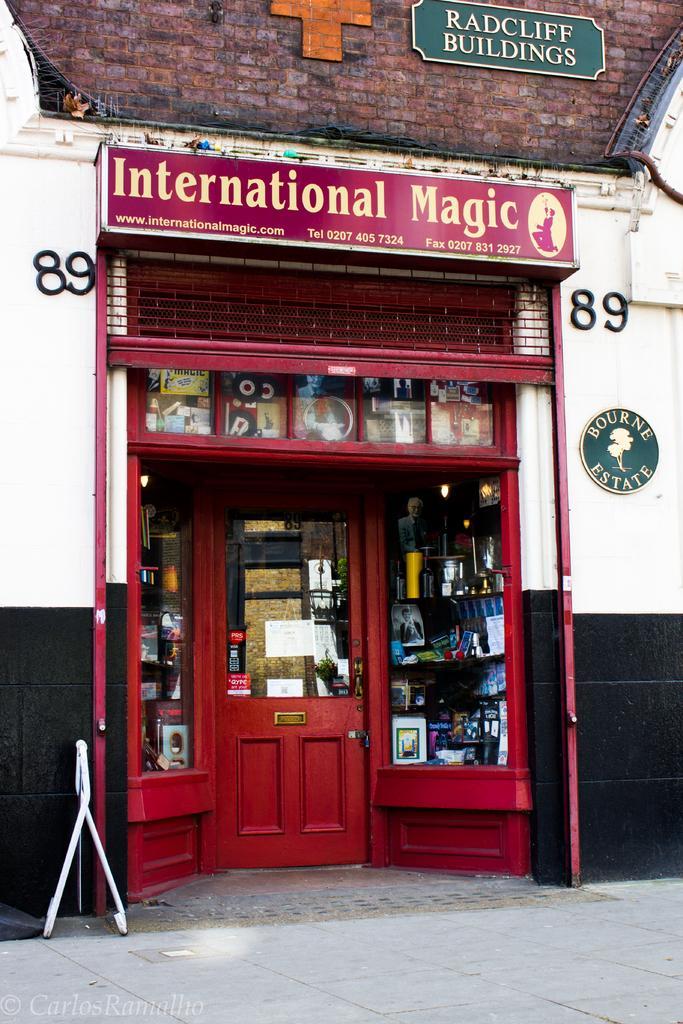How would you summarize this image in a sentence or two? There is a door, this is a building. 